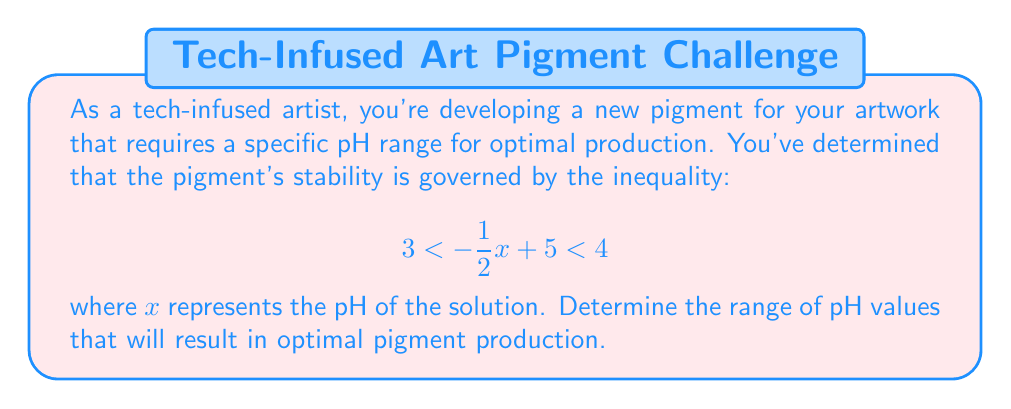Solve this math problem. To solve this problem, we need to manipulate the compound inequality to isolate $x$. Let's approach this step-by-step:

1) We start with the given inequality:
   $$ 3 < -\frac{1}{2}x + 5 < 4 $$

2) First, let's subtract 5 from all parts of the inequality:
   $$ -2 < -\frac{1}{2}x < -1 $$

3) Now, multiply all parts by -2 (remember to flip the inequality signs when multiplying by a negative number):
   $$ 4 > x > 2 $$

4) We can rewrite this in the conventional form:
   $$ 2 < x < 4 $$

5) Since $x$ represents the pH in this context, we can interpret this result as:
   The optimal pH range for pigment production is between 2 and 4, not including 2 and 4 themselves (as the original inequality used strict inequalities).

This means that any pH value greater than 2 and less than 4 will result in optimal pigment production.
Answer: The optimal pH range for pigment production is $2 < \text{pH} < 4$. 